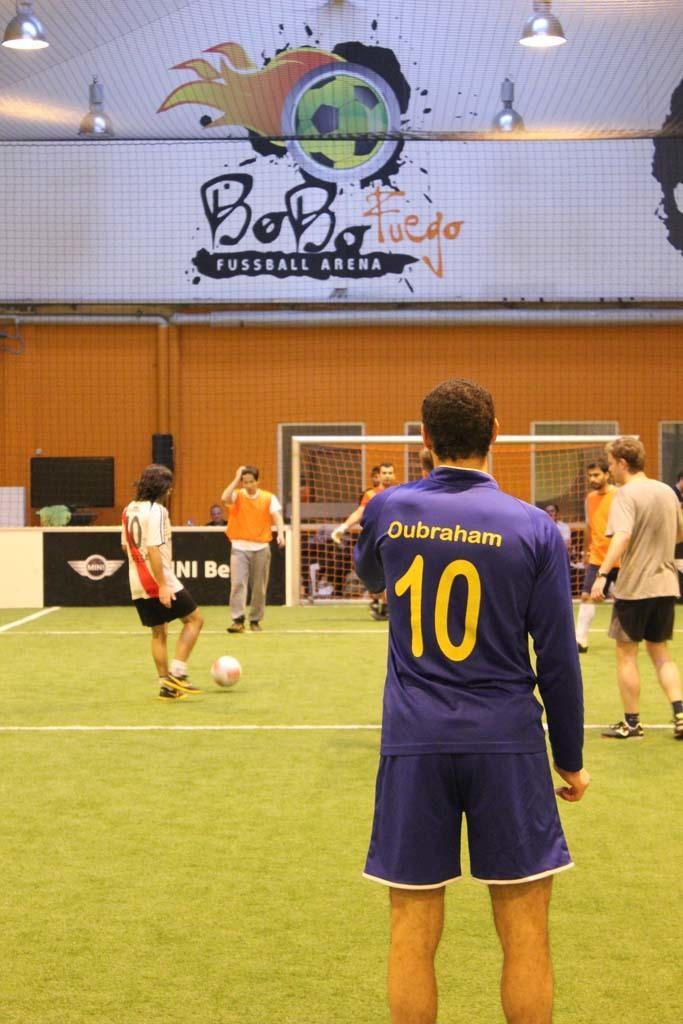Describe this image in one or two sentences. In the image few people are standing and there is a football. At the bottom of the image there is grass. Behind them there is a net and wall, on the wall there is painting and there are some lights. 